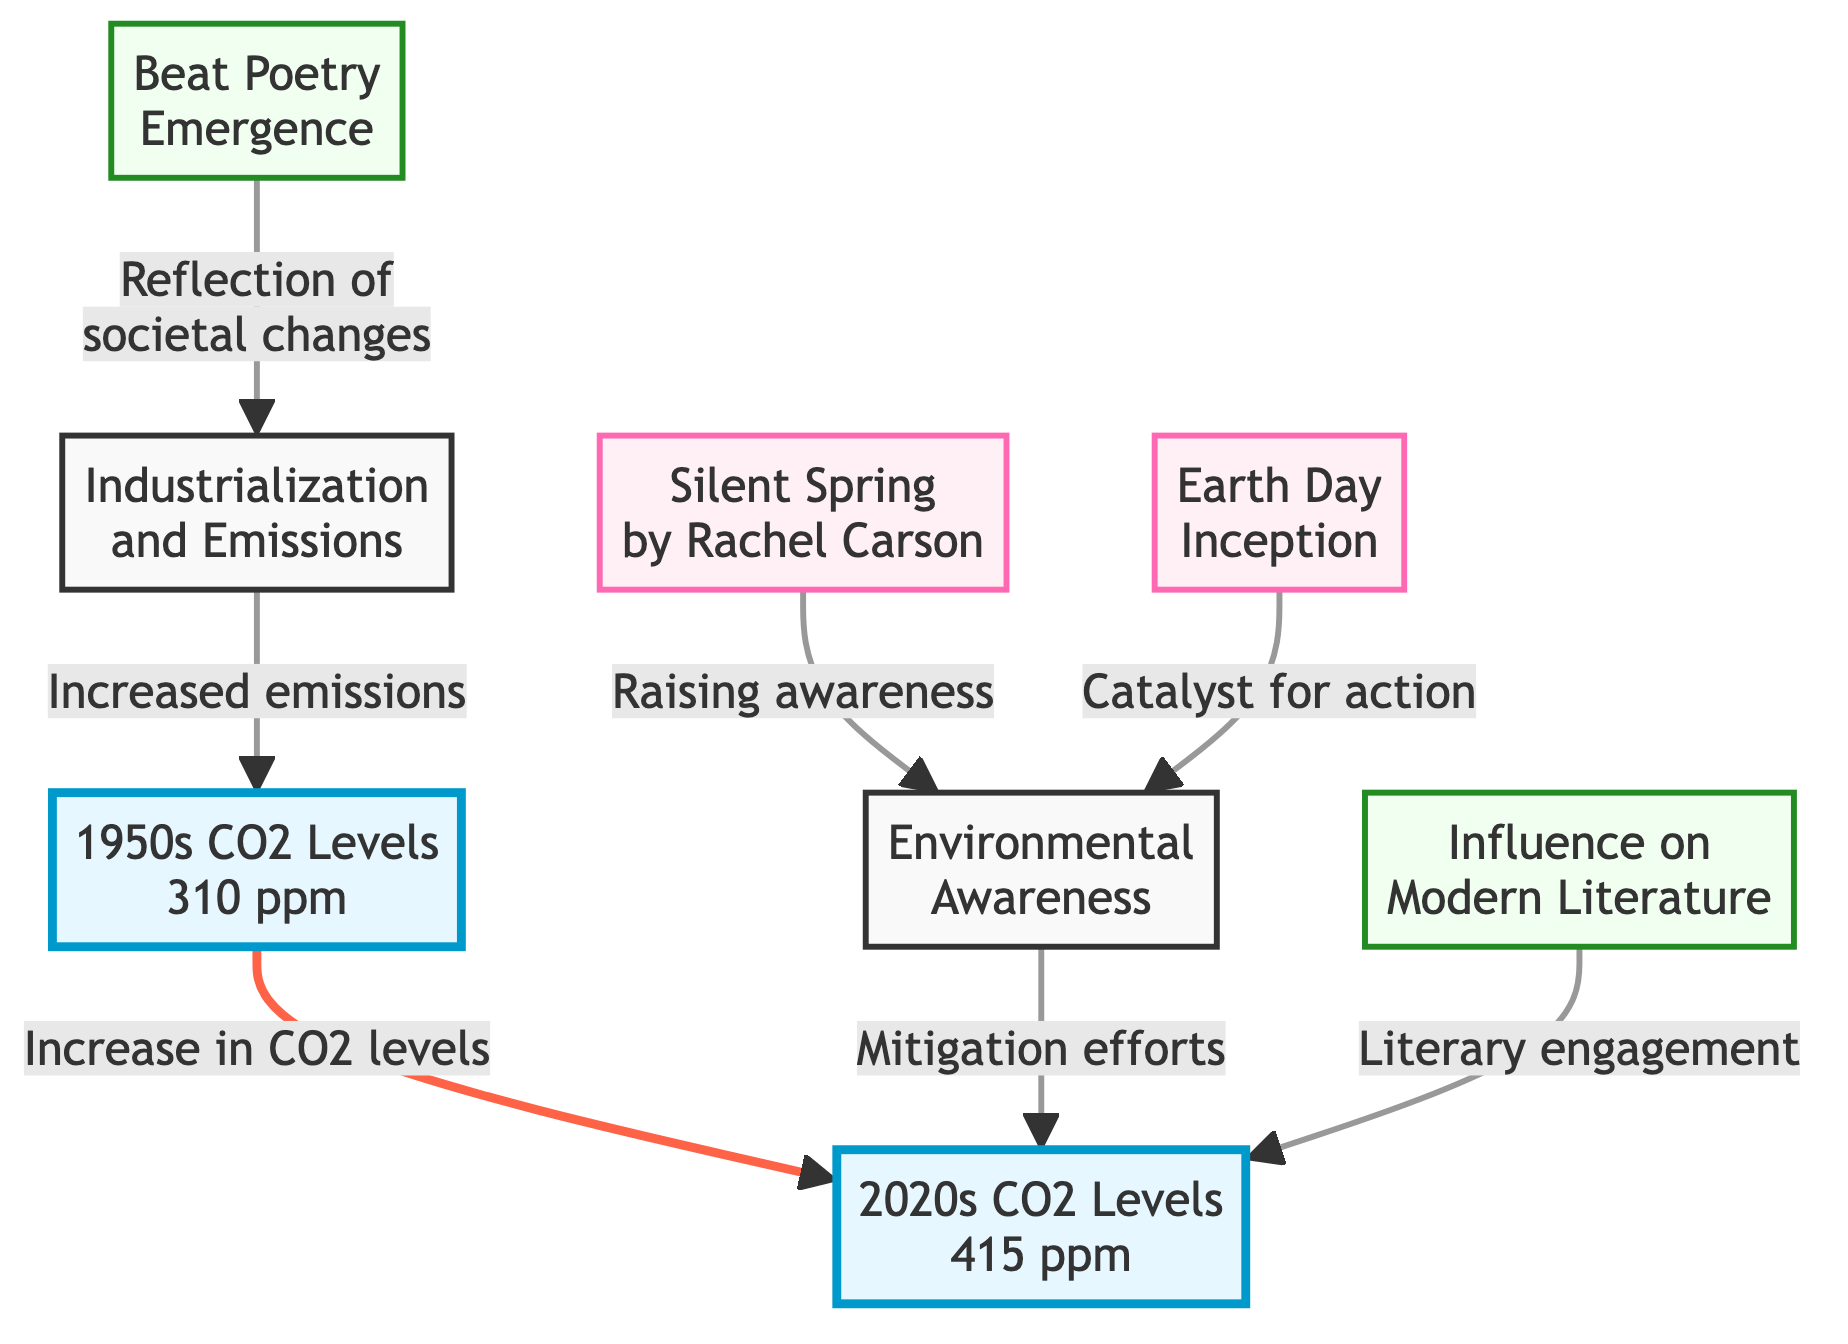What were the CO2 levels in the 1950s? The diagram states that the CO2 level in the 1950s was 310 ppm. This information is directly represented in the node labeled "1950s CO2 Levels."
Answer: 310 ppm What are the CO2 levels in the 2020s? According to the diagram, the CO2 level in the 2020s is 415 ppm, as indicated in the node labeled "2020s CO2 Levels."
Answer: 415 ppm What event is linked to "Raising awareness"? The diagram specifies that "Silent Spring by Rachel Carson" is connected to "Raising awareness," which is represented by the node labeled "Silent Spring."
Answer: Silent Spring What was the relationship between industrialization and CO2 levels? The arrow shows that there is an "Increased emissions" leading to the 310 ppm CO2 levels, indicating that industrialization caused higher emissions, thus affecting CO2 levels.
Answer: Increased emissions Which milestone is a catalyst for action? Referring to the diagram, "Earth Day Inception" is marked as a catalyst for action, connecting it to mitigation efforts in the node represented.
Answer: Earth Day Inception How many literary milestones are represented in the diagram? The diagram features two nodes that identify literary milestones: "Beat Poetry Emergence" and "Influence on Modern Literature," which indicates the presence of two literary milestones.
Answer: 2 What does the increase in CO2 levels from the 1950s to the 2020s indicate about environmental awareness? The diagram illustrates a link from "Mitigation efforts" to "2020s CO2 Levels," which suggests that the increase from 310 ppm to 415 ppm may have prompted greater awareness and action for the environment over time.
Answer: Greater awareness Which node reflects societal changes? The diagram shows that "Reflection of societal changes" is linked to the node for "Beat Poetry Emergence," indicating that this node is where societal changes are reflected.
Answer: Beat Poetry Emergence 